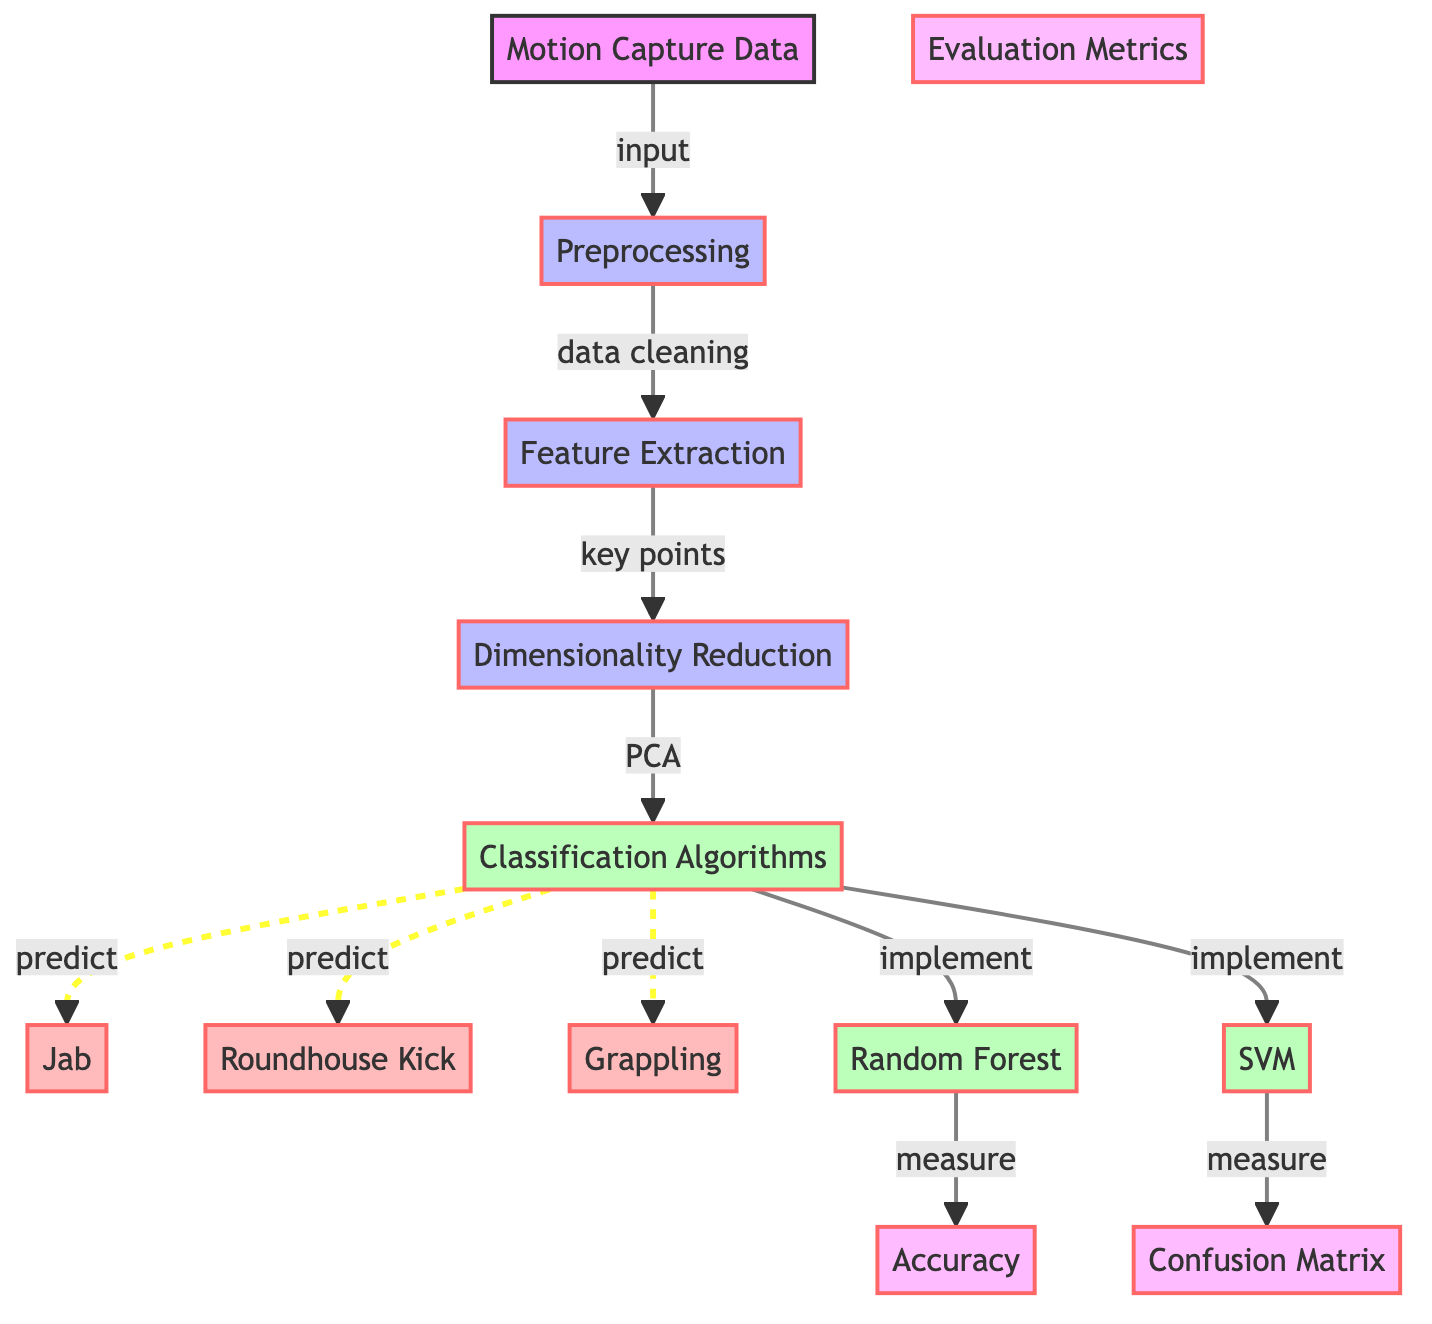What's the first step in the diagram? The first step in the diagram is "Motion Capture Data," which serves as the input for the subsequent processes.
Answer: Motion Capture Data How many classifications techniques are presented? The diagram shows three classification techniques: Jab, Roundhouse Kick, and Grappling. Counting these nodes gives the total.
Answer: 3 What process follows "Preprocessing"? After "Preprocessing," the next process is "Feature Extraction," which is a direct flow from the previous step.
Answer: Feature Extraction Which two classification algorithms are implemented? The diagram specifies two classification algorithms: Random Forest and SVM. These are listed in the corresponding section of the diagram.
Answer: Random Forest and SVM What metric is used to measure accuracy in the classification? The metric used to measure accuracy is labeled "Accuracy," which is connected to the Random Forest classification algorithm.
Answer: Accuracy Which dimensionality reduction technique is indicated in the diagram? The diagram mentions "PCA" (Principal Component Analysis) as the dimensionality reduction technique used after feature extraction.
Answer: PCA How does dimensionality reduction relate to the classification algorithms? Dimensionality reduction leads to the classification algorithms, which signifies that the data processed through PCA is fed into the classification algorithms for prediction.
Answer: Through classification algorithms What are the evaluation metrics mentioned in the diagram? The diagram lists two evaluation metrics: "Accuracy" and "Confusion Matrix." Both metrics are connected to the outputs of the classification algorithms.
Answer: Accuracy and Confusion Matrix What action is taken after "Classification Algorithms"? After "Classification Algorithms," the action taken is to "measure" performance metrics such as accuracy and confusion matrix, implying that these metrics evaluate the effectiveness of the classifications.
Answer: Measure 